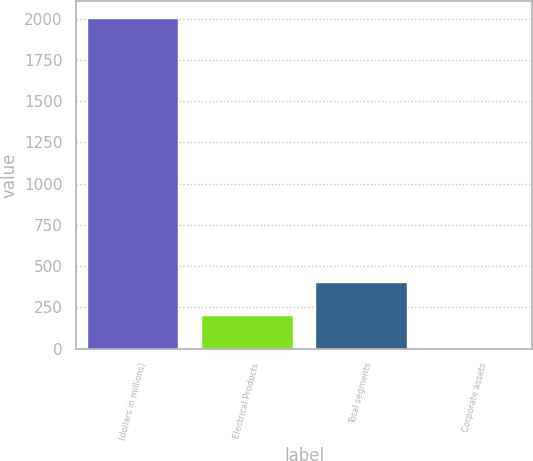Convert chart. <chart><loc_0><loc_0><loc_500><loc_500><bar_chart><fcel>(dollars in millions)<fcel>Electrical Products<fcel>Total segments<fcel>Corporate assets<nl><fcel>2006<fcel>201.05<fcel>401.6<fcel>0.5<nl></chart> 